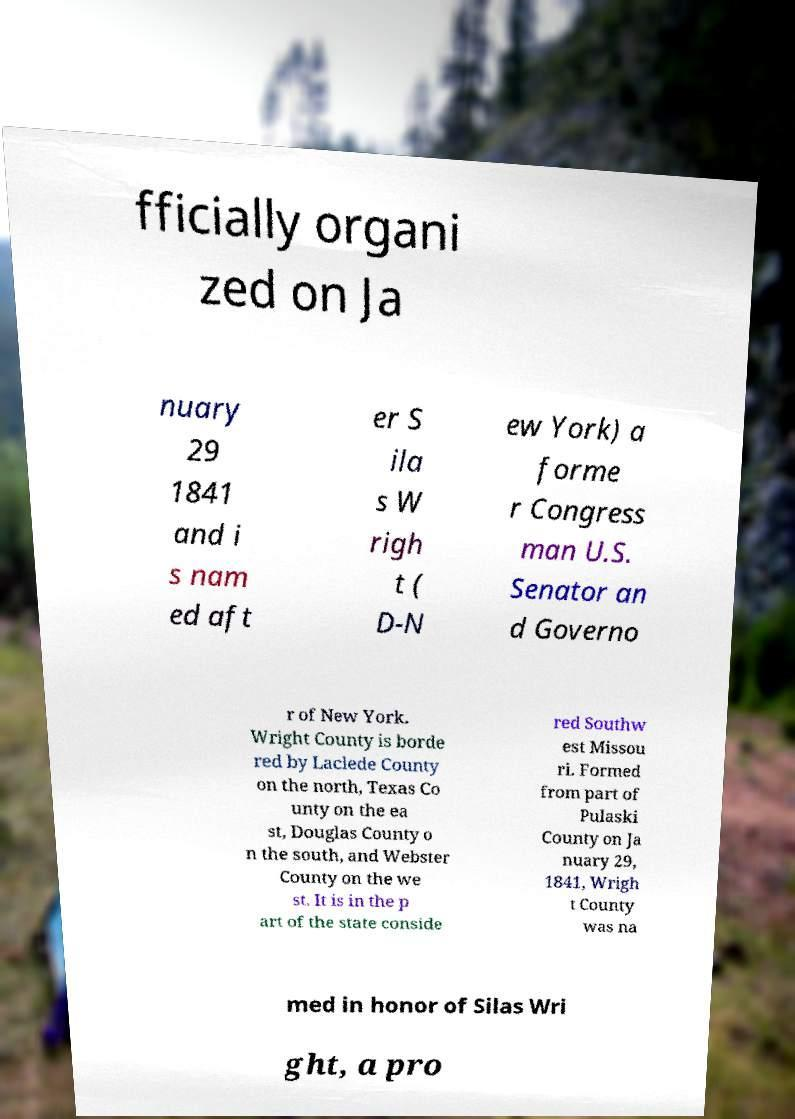Please identify and transcribe the text found in this image. fficially organi zed on Ja nuary 29 1841 and i s nam ed aft er S ila s W righ t ( D-N ew York) a forme r Congress man U.S. Senator an d Governo r of New York. Wright County is borde red by Laclede County on the north, Texas Co unty on the ea st, Douglas County o n the south, and Webster County on the we st. It is in the p art of the state conside red Southw est Missou ri. Formed from part of Pulaski County on Ja nuary 29, 1841, Wrigh t County was na med in honor of Silas Wri ght, a pro 